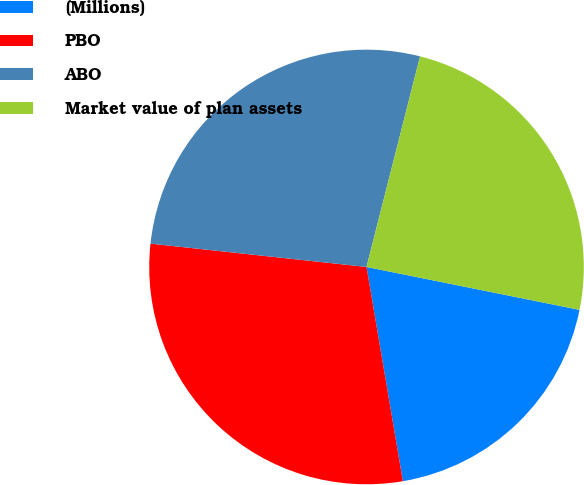<chart> <loc_0><loc_0><loc_500><loc_500><pie_chart><fcel>(Millions)<fcel>PBO<fcel>ABO<fcel>Market value of plan assets<nl><fcel>19.16%<fcel>29.39%<fcel>27.25%<fcel>24.2%<nl></chart> 